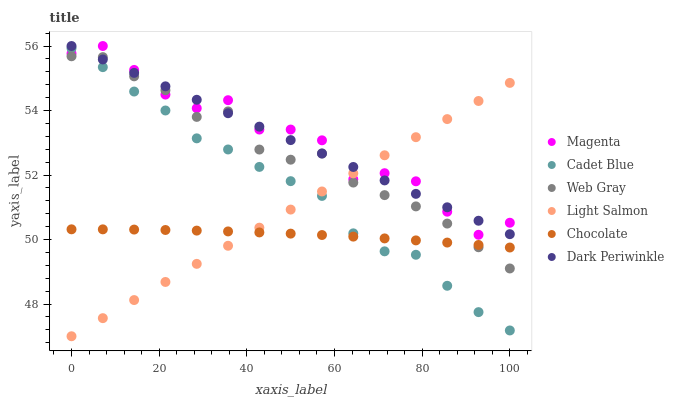Does Chocolate have the minimum area under the curve?
Answer yes or no. Yes. Does Magenta have the maximum area under the curve?
Answer yes or no. Yes. Does Cadet Blue have the minimum area under the curve?
Answer yes or no. No. Does Cadet Blue have the maximum area under the curve?
Answer yes or no. No. Is Dark Periwinkle the smoothest?
Answer yes or no. Yes. Is Magenta the roughest?
Answer yes or no. Yes. Is Cadet Blue the smoothest?
Answer yes or no. No. Is Cadet Blue the roughest?
Answer yes or no. No. Does Light Salmon have the lowest value?
Answer yes or no. Yes. Does Cadet Blue have the lowest value?
Answer yes or no. No. Does Dark Periwinkle have the highest value?
Answer yes or no. Yes. Does Cadet Blue have the highest value?
Answer yes or no. No. Is Chocolate less than Magenta?
Answer yes or no. Yes. Is Dark Periwinkle greater than Chocolate?
Answer yes or no. Yes. Does Magenta intersect Cadet Blue?
Answer yes or no. Yes. Is Magenta less than Cadet Blue?
Answer yes or no. No. Is Magenta greater than Cadet Blue?
Answer yes or no. No. Does Chocolate intersect Magenta?
Answer yes or no. No. 